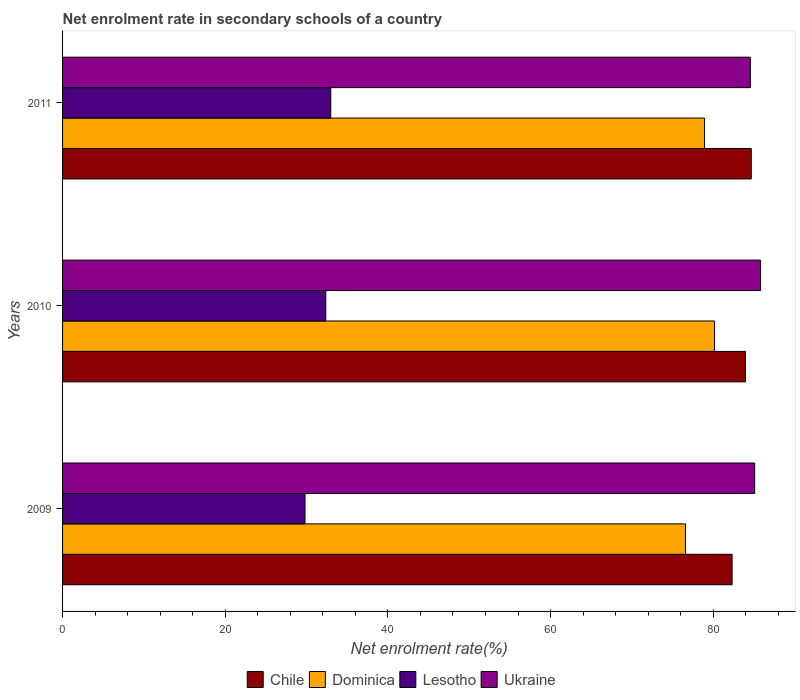How many different coloured bars are there?
Your answer should be very brief. 4. Are the number of bars on each tick of the Y-axis equal?
Your answer should be compact. Yes. How many bars are there on the 3rd tick from the bottom?
Keep it short and to the point. 4. In how many cases, is the number of bars for a given year not equal to the number of legend labels?
Offer a terse response. 0. What is the net enrolment rate in secondary schools in Dominica in 2009?
Make the answer very short. 76.59. Across all years, what is the maximum net enrolment rate in secondary schools in Chile?
Your answer should be very brief. 84.68. Across all years, what is the minimum net enrolment rate in secondary schools in Dominica?
Give a very brief answer. 76.59. What is the total net enrolment rate in secondary schools in Ukraine in the graph?
Your answer should be compact. 255.49. What is the difference between the net enrolment rate in secondary schools in Dominica in 2009 and that in 2011?
Your answer should be very brief. -2.34. What is the difference between the net enrolment rate in secondary schools in Ukraine in 2010 and the net enrolment rate in secondary schools in Chile in 2011?
Your answer should be compact. 1.15. What is the average net enrolment rate in secondary schools in Ukraine per year?
Give a very brief answer. 85.16. In the year 2010, what is the difference between the net enrolment rate in secondary schools in Ukraine and net enrolment rate in secondary schools in Dominica?
Provide a succinct answer. 5.67. In how many years, is the net enrolment rate in secondary schools in Dominica greater than 8 %?
Your response must be concise. 3. What is the ratio of the net enrolment rate in secondary schools in Chile in 2009 to that in 2010?
Give a very brief answer. 0.98. Is the net enrolment rate in secondary schools in Dominica in 2009 less than that in 2011?
Offer a terse response. Yes. Is the difference between the net enrolment rate in secondary schools in Ukraine in 2009 and 2010 greater than the difference between the net enrolment rate in secondary schools in Dominica in 2009 and 2010?
Keep it short and to the point. Yes. What is the difference between the highest and the second highest net enrolment rate in secondary schools in Dominica?
Provide a succinct answer. 1.22. What is the difference between the highest and the lowest net enrolment rate in secondary schools in Dominica?
Ensure brevity in your answer.  3.56. In how many years, is the net enrolment rate in secondary schools in Chile greater than the average net enrolment rate in secondary schools in Chile taken over all years?
Your answer should be very brief. 2. Is the sum of the net enrolment rate in secondary schools in Ukraine in 2009 and 2011 greater than the maximum net enrolment rate in secondary schools in Chile across all years?
Offer a very short reply. Yes. What does the 3rd bar from the top in 2011 represents?
Provide a short and direct response. Dominica. What does the 2nd bar from the bottom in 2009 represents?
Ensure brevity in your answer.  Dominica. Is it the case that in every year, the sum of the net enrolment rate in secondary schools in Lesotho and net enrolment rate in secondary schools in Chile is greater than the net enrolment rate in secondary schools in Ukraine?
Give a very brief answer. Yes. Are all the bars in the graph horizontal?
Offer a terse response. Yes. How many years are there in the graph?
Ensure brevity in your answer.  3. What is the difference between two consecutive major ticks on the X-axis?
Your response must be concise. 20. Are the values on the major ticks of X-axis written in scientific E-notation?
Keep it short and to the point. No. Does the graph contain any zero values?
Offer a very short reply. No. Does the graph contain grids?
Offer a very short reply. No. What is the title of the graph?
Your answer should be compact. Net enrolment rate in secondary schools of a country. What is the label or title of the X-axis?
Your answer should be very brief. Net enrolment rate(%). What is the label or title of the Y-axis?
Provide a short and direct response. Years. What is the Net enrolment rate(%) of Chile in 2009?
Offer a terse response. 82.32. What is the Net enrolment rate(%) of Dominica in 2009?
Offer a very short reply. 76.59. What is the Net enrolment rate(%) of Lesotho in 2009?
Give a very brief answer. 29.81. What is the Net enrolment rate(%) of Ukraine in 2009?
Your response must be concise. 85.1. What is the Net enrolment rate(%) in Chile in 2010?
Offer a very short reply. 83.97. What is the Net enrolment rate(%) in Dominica in 2010?
Keep it short and to the point. 80.16. What is the Net enrolment rate(%) of Lesotho in 2010?
Your response must be concise. 32.36. What is the Net enrolment rate(%) in Ukraine in 2010?
Ensure brevity in your answer.  85.83. What is the Net enrolment rate(%) of Chile in 2011?
Your response must be concise. 84.68. What is the Net enrolment rate(%) in Dominica in 2011?
Offer a terse response. 78.94. What is the Net enrolment rate(%) of Lesotho in 2011?
Give a very brief answer. 32.98. What is the Net enrolment rate(%) of Ukraine in 2011?
Make the answer very short. 84.57. Across all years, what is the maximum Net enrolment rate(%) of Chile?
Keep it short and to the point. 84.68. Across all years, what is the maximum Net enrolment rate(%) of Dominica?
Make the answer very short. 80.16. Across all years, what is the maximum Net enrolment rate(%) in Lesotho?
Keep it short and to the point. 32.98. Across all years, what is the maximum Net enrolment rate(%) of Ukraine?
Offer a terse response. 85.83. Across all years, what is the minimum Net enrolment rate(%) of Chile?
Your answer should be compact. 82.32. Across all years, what is the minimum Net enrolment rate(%) of Dominica?
Your answer should be very brief. 76.59. Across all years, what is the minimum Net enrolment rate(%) in Lesotho?
Provide a succinct answer. 29.81. Across all years, what is the minimum Net enrolment rate(%) of Ukraine?
Give a very brief answer. 84.57. What is the total Net enrolment rate(%) in Chile in the graph?
Your answer should be compact. 250.97. What is the total Net enrolment rate(%) of Dominica in the graph?
Provide a short and direct response. 235.69. What is the total Net enrolment rate(%) in Lesotho in the graph?
Make the answer very short. 95.15. What is the total Net enrolment rate(%) in Ukraine in the graph?
Offer a terse response. 255.49. What is the difference between the Net enrolment rate(%) in Chile in 2009 and that in 2010?
Your response must be concise. -1.64. What is the difference between the Net enrolment rate(%) of Dominica in 2009 and that in 2010?
Your answer should be very brief. -3.56. What is the difference between the Net enrolment rate(%) of Lesotho in 2009 and that in 2010?
Give a very brief answer. -2.55. What is the difference between the Net enrolment rate(%) in Ukraine in 2009 and that in 2010?
Your answer should be compact. -0.73. What is the difference between the Net enrolment rate(%) of Chile in 2009 and that in 2011?
Your answer should be compact. -2.36. What is the difference between the Net enrolment rate(%) in Dominica in 2009 and that in 2011?
Make the answer very short. -2.34. What is the difference between the Net enrolment rate(%) in Lesotho in 2009 and that in 2011?
Make the answer very short. -3.17. What is the difference between the Net enrolment rate(%) of Ukraine in 2009 and that in 2011?
Your response must be concise. 0.53. What is the difference between the Net enrolment rate(%) of Chile in 2010 and that in 2011?
Your answer should be compact. -0.71. What is the difference between the Net enrolment rate(%) of Dominica in 2010 and that in 2011?
Keep it short and to the point. 1.22. What is the difference between the Net enrolment rate(%) in Lesotho in 2010 and that in 2011?
Offer a very short reply. -0.62. What is the difference between the Net enrolment rate(%) of Ukraine in 2010 and that in 2011?
Provide a succinct answer. 1.26. What is the difference between the Net enrolment rate(%) of Chile in 2009 and the Net enrolment rate(%) of Dominica in 2010?
Offer a very short reply. 2.17. What is the difference between the Net enrolment rate(%) of Chile in 2009 and the Net enrolment rate(%) of Lesotho in 2010?
Ensure brevity in your answer.  49.96. What is the difference between the Net enrolment rate(%) in Chile in 2009 and the Net enrolment rate(%) in Ukraine in 2010?
Give a very brief answer. -3.5. What is the difference between the Net enrolment rate(%) of Dominica in 2009 and the Net enrolment rate(%) of Lesotho in 2010?
Give a very brief answer. 44.23. What is the difference between the Net enrolment rate(%) of Dominica in 2009 and the Net enrolment rate(%) of Ukraine in 2010?
Your answer should be compact. -9.23. What is the difference between the Net enrolment rate(%) of Lesotho in 2009 and the Net enrolment rate(%) of Ukraine in 2010?
Your answer should be compact. -56.01. What is the difference between the Net enrolment rate(%) in Chile in 2009 and the Net enrolment rate(%) in Dominica in 2011?
Offer a terse response. 3.39. What is the difference between the Net enrolment rate(%) in Chile in 2009 and the Net enrolment rate(%) in Lesotho in 2011?
Provide a succinct answer. 49.35. What is the difference between the Net enrolment rate(%) of Chile in 2009 and the Net enrolment rate(%) of Ukraine in 2011?
Provide a succinct answer. -2.24. What is the difference between the Net enrolment rate(%) of Dominica in 2009 and the Net enrolment rate(%) of Lesotho in 2011?
Offer a very short reply. 43.62. What is the difference between the Net enrolment rate(%) in Dominica in 2009 and the Net enrolment rate(%) in Ukraine in 2011?
Provide a succinct answer. -7.97. What is the difference between the Net enrolment rate(%) of Lesotho in 2009 and the Net enrolment rate(%) of Ukraine in 2011?
Your response must be concise. -54.75. What is the difference between the Net enrolment rate(%) in Chile in 2010 and the Net enrolment rate(%) in Dominica in 2011?
Ensure brevity in your answer.  5.03. What is the difference between the Net enrolment rate(%) of Chile in 2010 and the Net enrolment rate(%) of Lesotho in 2011?
Keep it short and to the point. 50.99. What is the difference between the Net enrolment rate(%) of Chile in 2010 and the Net enrolment rate(%) of Ukraine in 2011?
Your answer should be compact. -0.6. What is the difference between the Net enrolment rate(%) of Dominica in 2010 and the Net enrolment rate(%) of Lesotho in 2011?
Provide a succinct answer. 47.18. What is the difference between the Net enrolment rate(%) in Dominica in 2010 and the Net enrolment rate(%) in Ukraine in 2011?
Provide a short and direct response. -4.41. What is the difference between the Net enrolment rate(%) of Lesotho in 2010 and the Net enrolment rate(%) of Ukraine in 2011?
Offer a terse response. -52.2. What is the average Net enrolment rate(%) of Chile per year?
Offer a very short reply. 83.66. What is the average Net enrolment rate(%) in Dominica per year?
Ensure brevity in your answer.  78.56. What is the average Net enrolment rate(%) in Lesotho per year?
Ensure brevity in your answer.  31.72. What is the average Net enrolment rate(%) of Ukraine per year?
Keep it short and to the point. 85.16. In the year 2009, what is the difference between the Net enrolment rate(%) of Chile and Net enrolment rate(%) of Dominica?
Make the answer very short. 5.73. In the year 2009, what is the difference between the Net enrolment rate(%) of Chile and Net enrolment rate(%) of Lesotho?
Provide a short and direct response. 52.51. In the year 2009, what is the difference between the Net enrolment rate(%) in Chile and Net enrolment rate(%) in Ukraine?
Give a very brief answer. -2.78. In the year 2009, what is the difference between the Net enrolment rate(%) of Dominica and Net enrolment rate(%) of Lesotho?
Provide a succinct answer. 46.78. In the year 2009, what is the difference between the Net enrolment rate(%) of Dominica and Net enrolment rate(%) of Ukraine?
Make the answer very short. -8.51. In the year 2009, what is the difference between the Net enrolment rate(%) of Lesotho and Net enrolment rate(%) of Ukraine?
Your response must be concise. -55.29. In the year 2010, what is the difference between the Net enrolment rate(%) of Chile and Net enrolment rate(%) of Dominica?
Provide a succinct answer. 3.81. In the year 2010, what is the difference between the Net enrolment rate(%) in Chile and Net enrolment rate(%) in Lesotho?
Provide a short and direct response. 51.6. In the year 2010, what is the difference between the Net enrolment rate(%) of Chile and Net enrolment rate(%) of Ukraine?
Your answer should be very brief. -1.86. In the year 2010, what is the difference between the Net enrolment rate(%) in Dominica and Net enrolment rate(%) in Lesotho?
Your answer should be very brief. 47.8. In the year 2010, what is the difference between the Net enrolment rate(%) of Dominica and Net enrolment rate(%) of Ukraine?
Your answer should be compact. -5.67. In the year 2010, what is the difference between the Net enrolment rate(%) in Lesotho and Net enrolment rate(%) in Ukraine?
Your answer should be compact. -53.46. In the year 2011, what is the difference between the Net enrolment rate(%) in Chile and Net enrolment rate(%) in Dominica?
Offer a terse response. 5.74. In the year 2011, what is the difference between the Net enrolment rate(%) in Chile and Net enrolment rate(%) in Lesotho?
Offer a very short reply. 51.7. In the year 2011, what is the difference between the Net enrolment rate(%) of Chile and Net enrolment rate(%) of Ukraine?
Ensure brevity in your answer.  0.11. In the year 2011, what is the difference between the Net enrolment rate(%) in Dominica and Net enrolment rate(%) in Lesotho?
Offer a very short reply. 45.96. In the year 2011, what is the difference between the Net enrolment rate(%) in Dominica and Net enrolment rate(%) in Ukraine?
Your response must be concise. -5.63. In the year 2011, what is the difference between the Net enrolment rate(%) of Lesotho and Net enrolment rate(%) of Ukraine?
Provide a short and direct response. -51.59. What is the ratio of the Net enrolment rate(%) of Chile in 2009 to that in 2010?
Your response must be concise. 0.98. What is the ratio of the Net enrolment rate(%) of Dominica in 2009 to that in 2010?
Offer a very short reply. 0.96. What is the ratio of the Net enrolment rate(%) of Lesotho in 2009 to that in 2010?
Offer a very short reply. 0.92. What is the ratio of the Net enrolment rate(%) of Chile in 2009 to that in 2011?
Provide a succinct answer. 0.97. What is the ratio of the Net enrolment rate(%) of Dominica in 2009 to that in 2011?
Your answer should be compact. 0.97. What is the ratio of the Net enrolment rate(%) in Lesotho in 2009 to that in 2011?
Offer a very short reply. 0.9. What is the ratio of the Net enrolment rate(%) of Ukraine in 2009 to that in 2011?
Offer a very short reply. 1.01. What is the ratio of the Net enrolment rate(%) of Chile in 2010 to that in 2011?
Give a very brief answer. 0.99. What is the ratio of the Net enrolment rate(%) in Dominica in 2010 to that in 2011?
Provide a succinct answer. 1.02. What is the ratio of the Net enrolment rate(%) in Lesotho in 2010 to that in 2011?
Ensure brevity in your answer.  0.98. What is the ratio of the Net enrolment rate(%) of Ukraine in 2010 to that in 2011?
Provide a short and direct response. 1.01. What is the difference between the highest and the second highest Net enrolment rate(%) in Chile?
Provide a succinct answer. 0.71. What is the difference between the highest and the second highest Net enrolment rate(%) in Dominica?
Your answer should be very brief. 1.22. What is the difference between the highest and the second highest Net enrolment rate(%) in Lesotho?
Keep it short and to the point. 0.62. What is the difference between the highest and the second highest Net enrolment rate(%) in Ukraine?
Offer a terse response. 0.73. What is the difference between the highest and the lowest Net enrolment rate(%) in Chile?
Your answer should be very brief. 2.36. What is the difference between the highest and the lowest Net enrolment rate(%) of Dominica?
Make the answer very short. 3.56. What is the difference between the highest and the lowest Net enrolment rate(%) of Lesotho?
Your answer should be very brief. 3.17. What is the difference between the highest and the lowest Net enrolment rate(%) in Ukraine?
Your answer should be very brief. 1.26. 